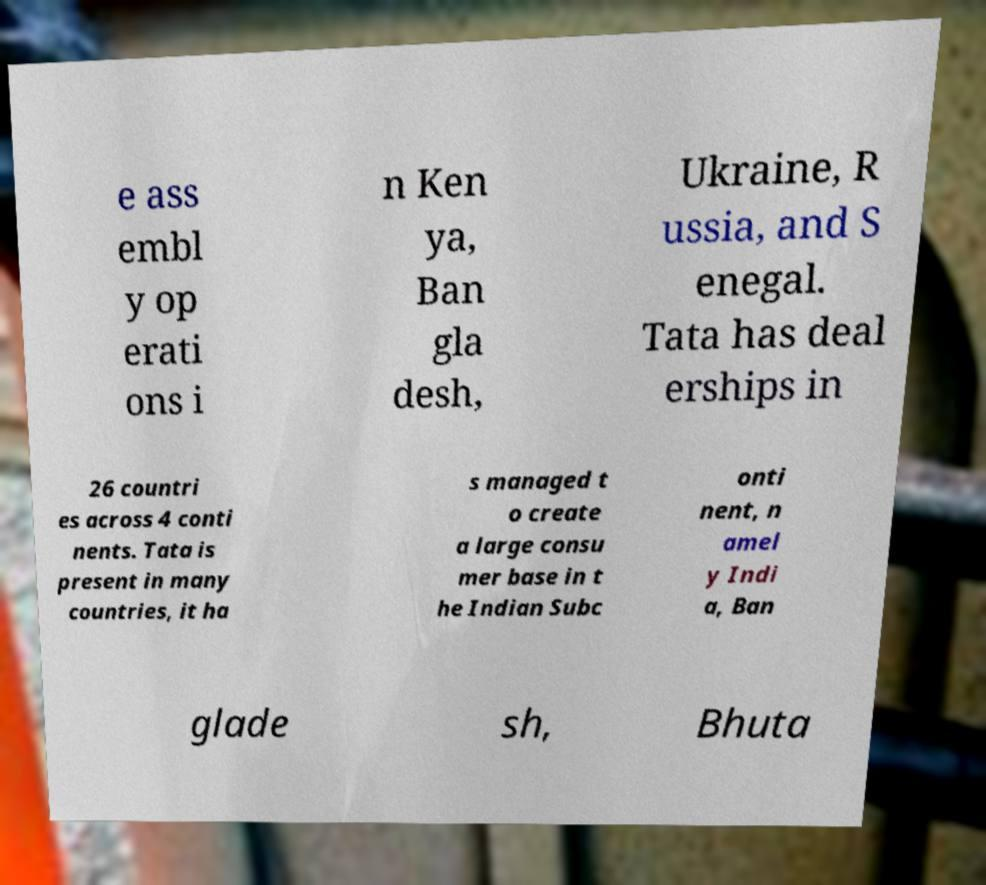Could you assist in decoding the text presented in this image and type it out clearly? e ass embl y op erati ons i n Ken ya, Ban gla desh, Ukraine, R ussia, and S enegal. Tata has deal erships in 26 countri es across 4 conti nents. Tata is present in many countries, it ha s managed t o create a large consu mer base in t he Indian Subc onti nent, n amel y Indi a, Ban glade sh, Bhuta 